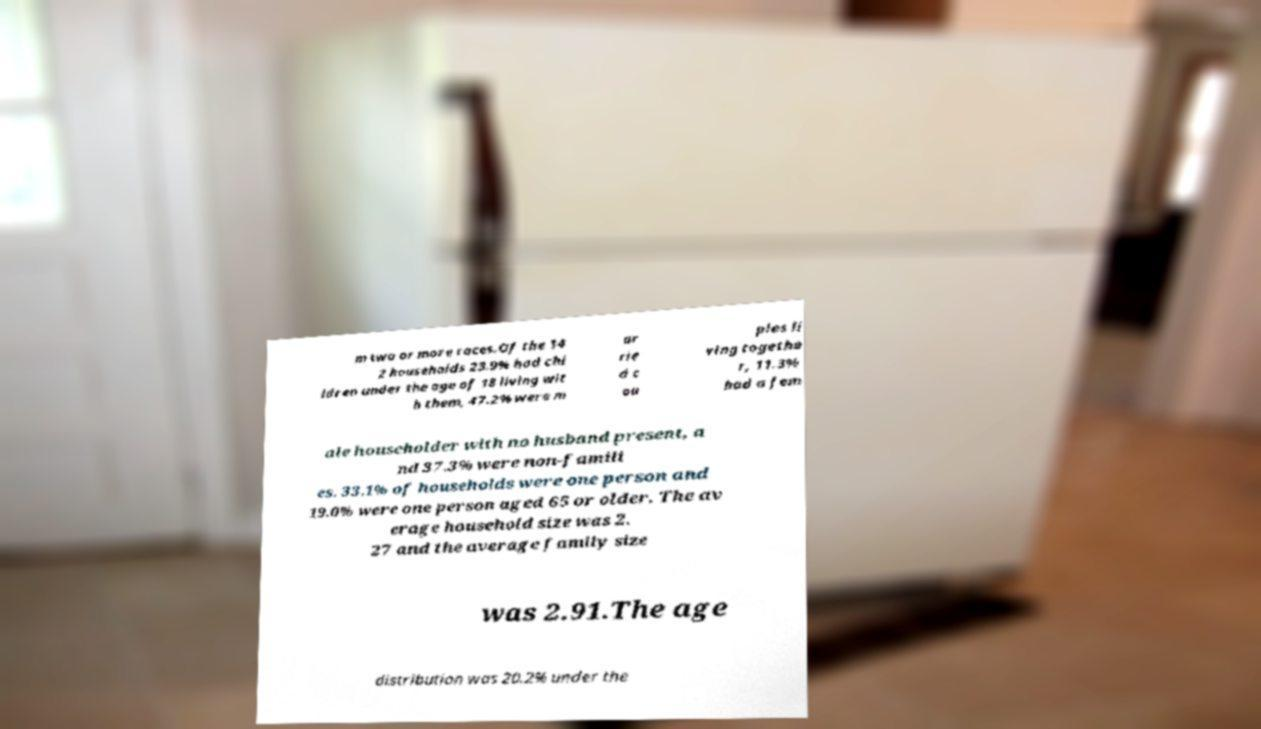Please read and relay the text visible in this image. What does it say? m two or more races.Of the 14 2 households 23.9% had chi ldren under the age of 18 living wit h them, 47.2% were m ar rie d c ou ples li ving togethe r, 11.3% had a fem ale householder with no husband present, a nd 37.3% were non-famili es. 33.1% of households were one person and 19.0% were one person aged 65 or older. The av erage household size was 2. 27 and the average family size was 2.91.The age distribution was 20.2% under the 